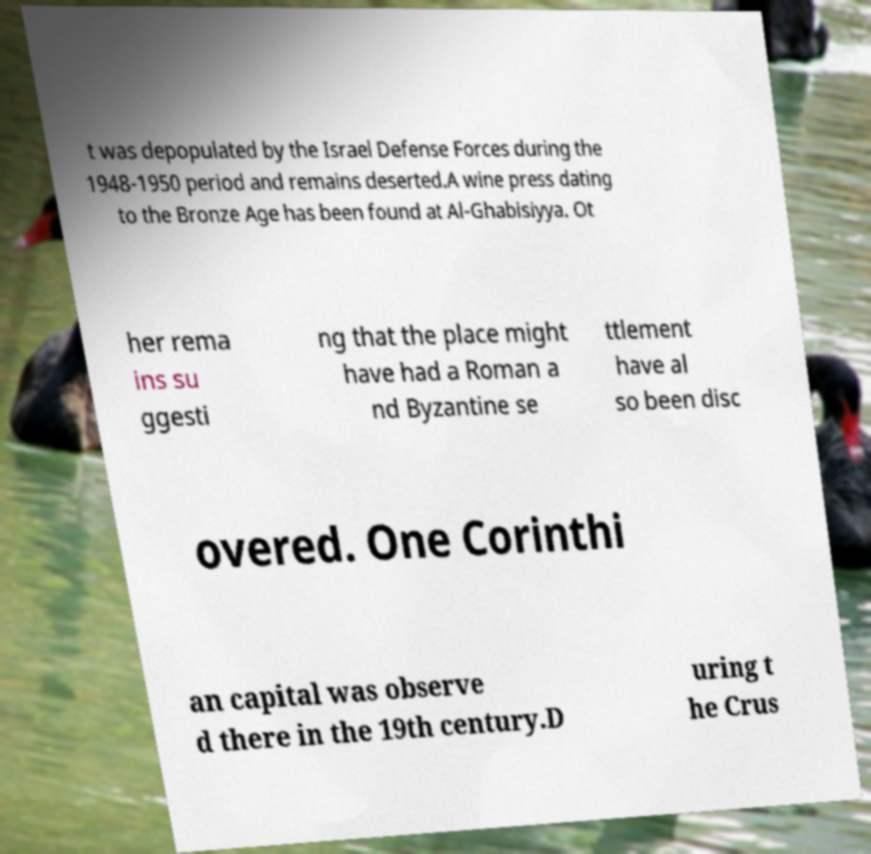For documentation purposes, I need the text within this image transcribed. Could you provide that? t was depopulated by the Israel Defense Forces during the 1948-1950 period and remains deserted.A wine press dating to the Bronze Age has been found at Al-Ghabisiyya. Ot her rema ins su ggesti ng that the place might have had a Roman a nd Byzantine se ttlement have al so been disc overed. One Corinthi an capital was observe d there in the 19th century.D uring t he Crus 